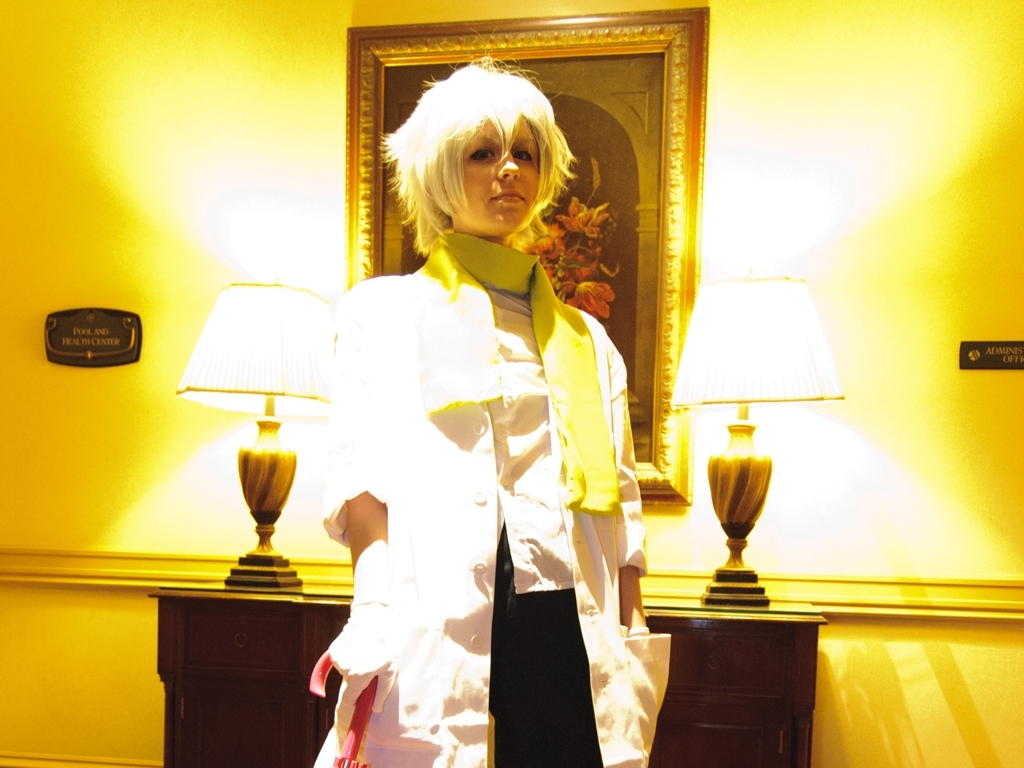Can you describe the person's costume in the image? The individual is clad in a white chef's coat with a high collar, paired with what appears to be a bright yellow neckerchief. The attire suggests a culinary theme, possibly representing a character known for cooking. 